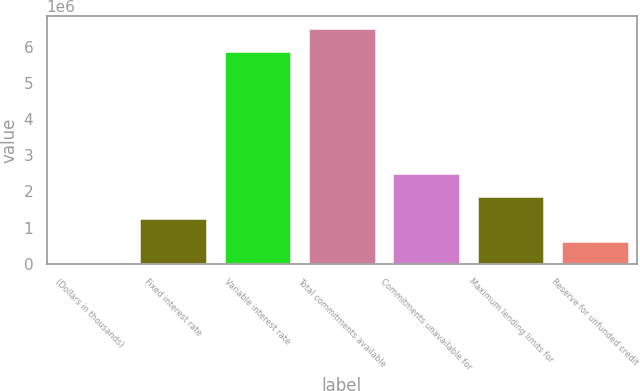Convert chart. <chart><loc_0><loc_0><loc_500><loc_500><bar_chart><fcel>(Dollars in thousands)<fcel>Fixed interest rate<fcel>Variable interest rate<fcel>Total commitments available<fcel>Commitments unavailable for<fcel>Maximum lending limits for<fcel>Reserve for unfunded credit<nl><fcel>2010<fcel>1.25571e+06<fcel>5.88445e+06<fcel>6.5113e+06<fcel>2.50941e+06<fcel>1.88256e+06<fcel>628860<nl></chart> 